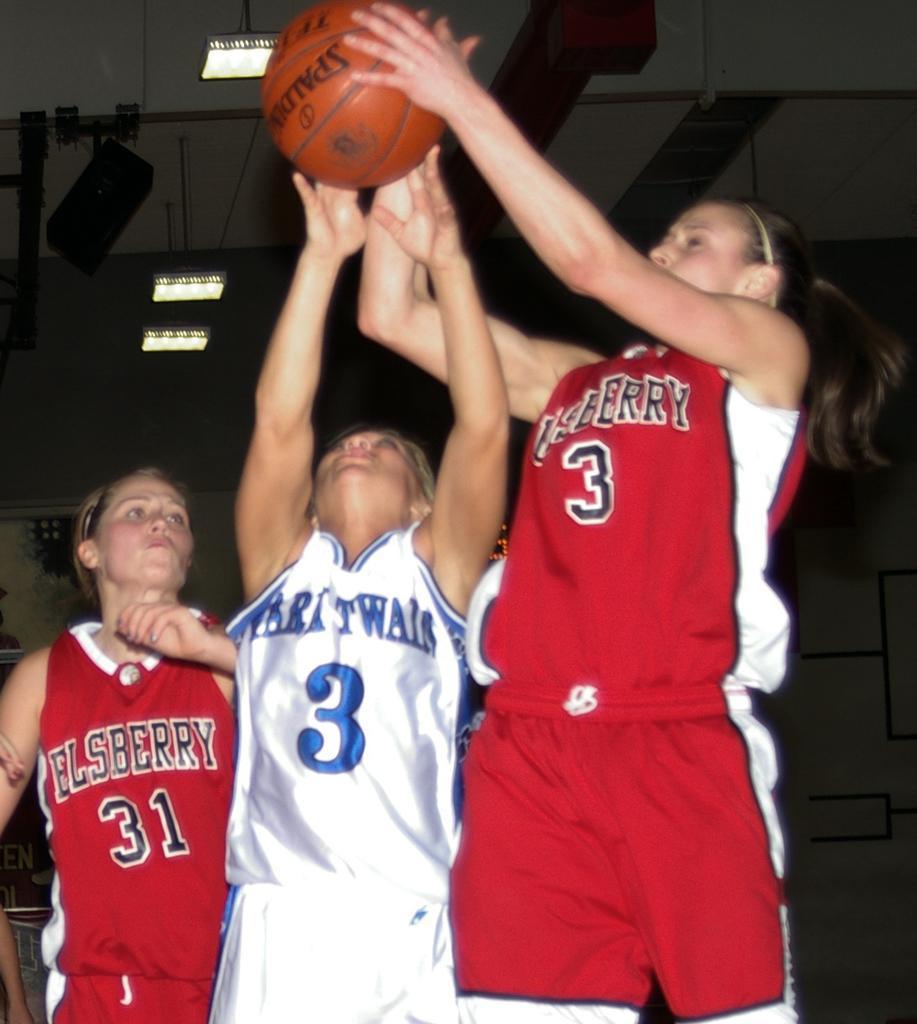How would you summarize this image in a sentence or two? This image consists of three women playing basketball. They are wearing jerseys. At the top, there is a roof. The jerseys are in white and red color. 